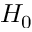<formula> <loc_0><loc_0><loc_500><loc_500>H _ { 0 }</formula> 